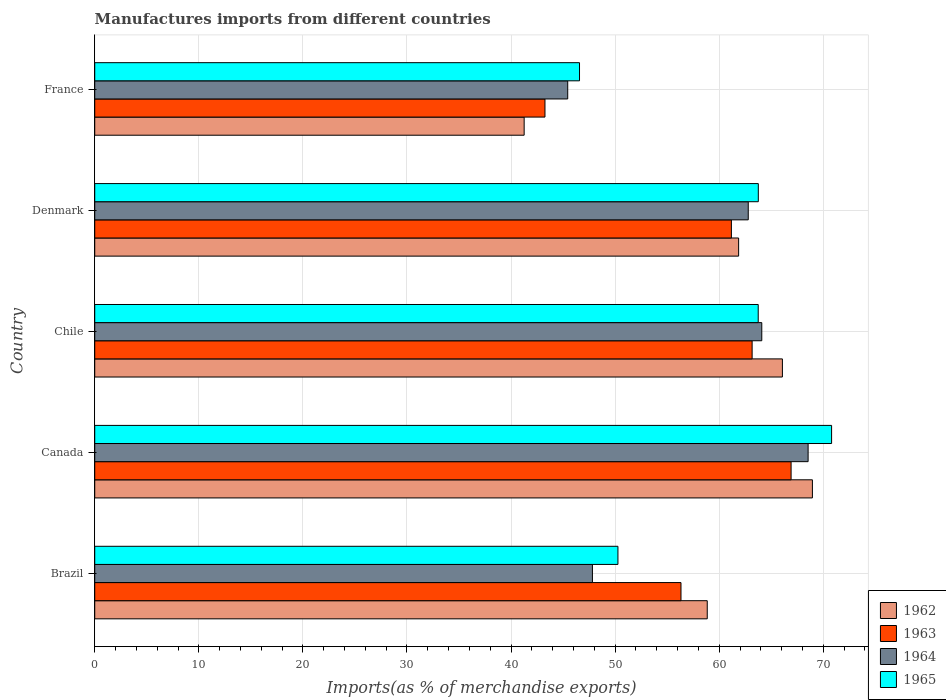How many different coloured bars are there?
Offer a very short reply. 4. How many groups of bars are there?
Your answer should be compact. 5. Are the number of bars per tick equal to the number of legend labels?
Provide a short and direct response. Yes. Are the number of bars on each tick of the Y-axis equal?
Your answer should be compact. Yes. How many bars are there on the 4th tick from the top?
Your answer should be compact. 4. What is the label of the 2nd group of bars from the top?
Offer a very short reply. Denmark. In how many cases, is the number of bars for a given country not equal to the number of legend labels?
Provide a short and direct response. 0. What is the percentage of imports to different countries in 1962 in Brazil?
Your answer should be very brief. 58.85. Across all countries, what is the maximum percentage of imports to different countries in 1965?
Give a very brief answer. 70.79. Across all countries, what is the minimum percentage of imports to different countries in 1962?
Offer a very short reply. 41.26. In which country was the percentage of imports to different countries in 1962 maximum?
Provide a succinct answer. Canada. What is the total percentage of imports to different countries in 1965 in the graph?
Your answer should be compact. 295.13. What is the difference between the percentage of imports to different countries in 1965 in Brazil and that in Chile?
Your response must be concise. -13.48. What is the difference between the percentage of imports to different countries in 1963 in France and the percentage of imports to different countries in 1962 in Canada?
Give a very brief answer. -25.69. What is the average percentage of imports to different countries in 1964 per country?
Make the answer very short. 57.73. What is the difference between the percentage of imports to different countries in 1962 and percentage of imports to different countries in 1963 in Canada?
Your response must be concise. 2.05. In how many countries, is the percentage of imports to different countries in 1964 greater than 14 %?
Your response must be concise. 5. What is the ratio of the percentage of imports to different countries in 1962 in Canada to that in France?
Ensure brevity in your answer.  1.67. Is the percentage of imports to different countries in 1964 in Chile less than that in Denmark?
Provide a short and direct response. No. Is the difference between the percentage of imports to different countries in 1962 in Chile and France greater than the difference between the percentage of imports to different countries in 1963 in Chile and France?
Make the answer very short. Yes. What is the difference between the highest and the second highest percentage of imports to different countries in 1964?
Provide a short and direct response. 4.45. What is the difference between the highest and the lowest percentage of imports to different countries in 1963?
Keep it short and to the point. 23.65. Is the sum of the percentage of imports to different countries in 1965 in Canada and Chile greater than the maximum percentage of imports to different countries in 1963 across all countries?
Offer a very short reply. Yes. Is it the case that in every country, the sum of the percentage of imports to different countries in 1965 and percentage of imports to different countries in 1963 is greater than the sum of percentage of imports to different countries in 1962 and percentage of imports to different countries in 1964?
Offer a very short reply. No. What does the 2nd bar from the top in Denmark represents?
Your answer should be very brief. 1964. What does the 4th bar from the bottom in Canada represents?
Your response must be concise. 1965. Is it the case that in every country, the sum of the percentage of imports to different countries in 1963 and percentage of imports to different countries in 1964 is greater than the percentage of imports to different countries in 1962?
Provide a succinct answer. Yes. Are all the bars in the graph horizontal?
Provide a short and direct response. Yes. How many countries are there in the graph?
Make the answer very short. 5. How many legend labels are there?
Your response must be concise. 4. What is the title of the graph?
Provide a succinct answer. Manufactures imports from different countries. What is the label or title of the X-axis?
Make the answer very short. Imports(as % of merchandise exports). What is the label or title of the Y-axis?
Provide a succinct answer. Country. What is the Imports(as % of merchandise exports) of 1962 in Brazil?
Offer a terse response. 58.85. What is the Imports(as % of merchandise exports) in 1963 in Brazil?
Give a very brief answer. 56.32. What is the Imports(as % of merchandise exports) of 1964 in Brazil?
Make the answer very short. 47.82. What is the Imports(as % of merchandise exports) of 1965 in Brazil?
Your answer should be very brief. 50.27. What is the Imports(as % of merchandise exports) in 1962 in Canada?
Offer a terse response. 68.95. What is the Imports(as % of merchandise exports) in 1963 in Canada?
Provide a short and direct response. 66.9. What is the Imports(as % of merchandise exports) of 1964 in Canada?
Your answer should be very brief. 68.54. What is the Imports(as % of merchandise exports) in 1965 in Canada?
Keep it short and to the point. 70.79. What is the Imports(as % of merchandise exports) of 1962 in Chile?
Offer a terse response. 66.07. What is the Imports(as % of merchandise exports) of 1963 in Chile?
Ensure brevity in your answer.  63.16. What is the Imports(as % of merchandise exports) of 1964 in Chile?
Your response must be concise. 64.09. What is the Imports(as % of merchandise exports) of 1965 in Chile?
Offer a very short reply. 63.74. What is the Imports(as % of merchandise exports) of 1962 in Denmark?
Your answer should be very brief. 61.86. What is the Imports(as % of merchandise exports) of 1963 in Denmark?
Provide a short and direct response. 61.17. What is the Imports(as % of merchandise exports) in 1964 in Denmark?
Make the answer very short. 62.79. What is the Imports(as % of merchandise exports) in 1965 in Denmark?
Make the answer very short. 63.75. What is the Imports(as % of merchandise exports) of 1962 in France?
Your response must be concise. 41.26. What is the Imports(as % of merchandise exports) of 1963 in France?
Offer a terse response. 43.26. What is the Imports(as % of merchandise exports) of 1964 in France?
Your response must be concise. 45.44. What is the Imports(as % of merchandise exports) in 1965 in France?
Offer a very short reply. 46.57. Across all countries, what is the maximum Imports(as % of merchandise exports) of 1962?
Your response must be concise. 68.95. Across all countries, what is the maximum Imports(as % of merchandise exports) of 1963?
Give a very brief answer. 66.9. Across all countries, what is the maximum Imports(as % of merchandise exports) of 1964?
Your answer should be very brief. 68.54. Across all countries, what is the maximum Imports(as % of merchandise exports) of 1965?
Make the answer very short. 70.79. Across all countries, what is the minimum Imports(as % of merchandise exports) in 1962?
Your response must be concise. 41.26. Across all countries, what is the minimum Imports(as % of merchandise exports) of 1963?
Offer a very short reply. 43.26. Across all countries, what is the minimum Imports(as % of merchandise exports) in 1964?
Give a very brief answer. 45.44. Across all countries, what is the minimum Imports(as % of merchandise exports) of 1965?
Offer a terse response. 46.57. What is the total Imports(as % of merchandise exports) of 1962 in the graph?
Make the answer very short. 296.98. What is the total Imports(as % of merchandise exports) of 1963 in the graph?
Provide a short and direct response. 290.81. What is the total Imports(as % of merchandise exports) in 1964 in the graph?
Your answer should be very brief. 288.67. What is the total Imports(as % of merchandise exports) in 1965 in the graph?
Make the answer very short. 295.13. What is the difference between the Imports(as % of merchandise exports) in 1962 in Brazil and that in Canada?
Your response must be concise. -10.1. What is the difference between the Imports(as % of merchandise exports) in 1963 in Brazil and that in Canada?
Offer a very short reply. -10.58. What is the difference between the Imports(as % of merchandise exports) of 1964 in Brazil and that in Canada?
Your answer should be compact. -20.72. What is the difference between the Imports(as % of merchandise exports) of 1965 in Brazil and that in Canada?
Offer a very short reply. -20.53. What is the difference between the Imports(as % of merchandise exports) of 1962 in Brazil and that in Chile?
Provide a short and direct response. -7.22. What is the difference between the Imports(as % of merchandise exports) in 1963 in Brazil and that in Chile?
Your answer should be very brief. -6.84. What is the difference between the Imports(as % of merchandise exports) of 1964 in Brazil and that in Chile?
Your answer should be compact. -16.27. What is the difference between the Imports(as % of merchandise exports) in 1965 in Brazil and that in Chile?
Your answer should be compact. -13.48. What is the difference between the Imports(as % of merchandise exports) of 1962 in Brazil and that in Denmark?
Make the answer very short. -3.01. What is the difference between the Imports(as % of merchandise exports) of 1963 in Brazil and that in Denmark?
Your response must be concise. -4.84. What is the difference between the Imports(as % of merchandise exports) of 1964 in Brazil and that in Denmark?
Make the answer very short. -14.97. What is the difference between the Imports(as % of merchandise exports) in 1965 in Brazil and that in Denmark?
Ensure brevity in your answer.  -13.49. What is the difference between the Imports(as % of merchandise exports) in 1962 in Brazil and that in France?
Offer a terse response. 17.59. What is the difference between the Imports(as % of merchandise exports) in 1963 in Brazil and that in France?
Offer a very short reply. 13.07. What is the difference between the Imports(as % of merchandise exports) in 1964 in Brazil and that in France?
Offer a very short reply. 2.37. What is the difference between the Imports(as % of merchandise exports) in 1965 in Brazil and that in France?
Provide a succinct answer. 3.69. What is the difference between the Imports(as % of merchandise exports) in 1962 in Canada and that in Chile?
Provide a short and direct response. 2.88. What is the difference between the Imports(as % of merchandise exports) in 1963 in Canada and that in Chile?
Keep it short and to the point. 3.74. What is the difference between the Imports(as % of merchandise exports) of 1964 in Canada and that in Chile?
Your response must be concise. 4.45. What is the difference between the Imports(as % of merchandise exports) of 1965 in Canada and that in Chile?
Your answer should be compact. 7.05. What is the difference between the Imports(as % of merchandise exports) in 1962 in Canada and that in Denmark?
Provide a short and direct response. 7.09. What is the difference between the Imports(as % of merchandise exports) of 1963 in Canada and that in Denmark?
Provide a short and direct response. 5.74. What is the difference between the Imports(as % of merchandise exports) in 1964 in Canada and that in Denmark?
Provide a succinct answer. 5.75. What is the difference between the Imports(as % of merchandise exports) of 1965 in Canada and that in Denmark?
Give a very brief answer. 7.04. What is the difference between the Imports(as % of merchandise exports) of 1962 in Canada and that in France?
Offer a terse response. 27.69. What is the difference between the Imports(as % of merchandise exports) in 1963 in Canada and that in France?
Your response must be concise. 23.65. What is the difference between the Imports(as % of merchandise exports) of 1964 in Canada and that in France?
Keep it short and to the point. 23.1. What is the difference between the Imports(as % of merchandise exports) in 1965 in Canada and that in France?
Give a very brief answer. 24.22. What is the difference between the Imports(as % of merchandise exports) of 1962 in Chile and that in Denmark?
Give a very brief answer. 4.21. What is the difference between the Imports(as % of merchandise exports) of 1963 in Chile and that in Denmark?
Your answer should be very brief. 1.99. What is the difference between the Imports(as % of merchandise exports) of 1964 in Chile and that in Denmark?
Your response must be concise. 1.3. What is the difference between the Imports(as % of merchandise exports) in 1965 in Chile and that in Denmark?
Keep it short and to the point. -0.01. What is the difference between the Imports(as % of merchandise exports) of 1962 in Chile and that in France?
Provide a succinct answer. 24.81. What is the difference between the Imports(as % of merchandise exports) of 1963 in Chile and that in France?
Your answer should be compact. 19.9. What is the difference between the Imports(as % of merchandise exports) of 1964 in Chile and that in France?
Keep it short and to the point. 18.64. What is the difference between the Imports(as % of merchandise exports) of 1965 in Chile and that in France?
Your answer should be very brief. 17.17. What is the difference between the Imports(as % of merchandise exports) of 1962 in Denmark and that in France?
Offer a very short reply. 20.61. What is the difference between the Imports(as % of merchandise exports) of 1963 in Denmark and that in France?
Your answer should be very brief. 17.91. What is the difference between the Imports(as % of merchandise exports) in 1964 in Denmark and that in France?
Keep it short and to the point. 17.34. What is the difference between the Imports(as % of merchandise exports) in 1965 in Denmark and that in France?
Make the answer very short. 17.18. What is the difference between the Imports(as % of merchandise exports) in 1962 in Brazil and the Imports(as % of merchandise exports) in 1963 in Canada?
Provide a succinct answer. -8.06. What is the difference between the Imports(as % of merchandise exports) of 1962 in Brazil and the Imports(as % of merchandise exports) of 1964 in Canada?
Your answer should be compact. -9.69. What is the difference between the Imports(as % of merchandise exports) in 1962 in Brazil and the Imports(as % of merchandise exports) in 1965 in Canada?
Provide a short and direct response. -11.95. What is the difference between the Imports(as % of merchandise exports) in 1963 in Brazil and the Imports(as % of merchandise exports) in 1964 in Canada?
Offer a very short reply. -12.21. What is the difference between the Imports(as % of merchandise exports) in 1963 in Brazil and the Imports(as % of merchandise exports) in 1965 in Canada?
Offer a terse response. -14.47. What is the difference between the Imports(as % of merchandise exports) of 1964 in Brazil and the Imports(as % of merchandise exports) of 1965 in Canada?
Your answer should be very brief. -22.98. What is the difference between the Imports(as % of merchandise exports) in 1962 in Brazil and the Imports(as % of merchandise exports) in 1963 in Chile?
Provide a short and direct response. -4.31. What is the difference between the Imports(as % of merchandise exports) in 1962 in Brazil and the Imports(as % of merchandise exports) in 1964 in Chile?
Your answer should be very brief. -5.24. What is the difference between the Imports(as % of merchandise exports) of 1962 in Brazil and the Imports(as % of merchandise exports) of 1965 in Chile?
Provide a succinct answer. -4.9. What is the difference between the Imports(as % of merchandise exports) of 1963 in Brazil and the Imports(as % of merchandise exports) of 1964 in Chile?
Your response must be concise. -7.76. What is the difference between the Imports(as % of merchandise exports) of 1963 in Brazil and the Imports(as % of merchandise exports) of 1965 in Chile?
Offer a terse response. -7.42. What is the difference between the Imports(as % of merchandise exports) in 1964 in Brazil and the Imports(as % of merchandise exports) in 1965 in Chile?
Keep it short and to the point. -15.93. What is the difference between the Imports(as % of merchandise exports) in 1962 in Brazil and the Imports(as % of merchandise exports) in 1963 in Denmark?
Your answer should be very brief. -2.32. What is the difference between the Imports(as % of merchandise exports) in 1962 in Brazil and the Imports(as % of merchandise exports) in 1964 in Denmark?
Provide a succinct answer. -3.94. What is the difference between the Imports(as % of merchandise exports) of 1962 in Brazil and the Imports(as % of merchandise exports) of 1965 in Denmark?
Provide a succinct answer. -4.91. What is the difference between the Imports(as % of merchandise exports) of 1963 in Brazil and the Imports(as % of merchandise exports) of 1964 in Denmark?
Make the answer very short. -6.46. What is the difference between the Imports(as % of merchandise exports) of 1963 in Brazil and the Imports(as % of merchandise exports) of 1965 in Denmark?
Your answer should be compact. -7.43. What is the difference between the Imports(as % of merchandise exports) of 1964 in Brazil and the Imports(as % of merchandise exports) of 1965 in Denmark?
Your answer should be compact. -15.94. What is the difference between the Imports(as % of merchandise exports) of 1962 in Brazil and the Imports(as % of merchandise exports) of 1963 in France?
Give a very brief answer. 15.59. What is the difference between the Imports(as % of merchandise exports) in 1962 in Brazil and the Imports(as % of merchandise exports) in 1964 in France?
Your response must be concise. 13.4. What is the difference between the Imports(as % of merchandise exports) in 1962 in Brazil and the Imports(as % of merchandise exports) in 1965 in France?
Your answer should be very brief. 12.27. What is the difference between the Imports(as % of merchandise exports) of 1963 in Brazil and the Imports(as % of merchandise exports) of 1964 in France?
Provide a short and direct response. 10.88. What is the difference between the Imports(as % of merchandise exports) of 1963 in Brazil and the Imports(as % of merchandise exports) of 1965 in France?
Your answer should be very brief. 9.75. What is the difference between the Imports(as % of merchandise exports) of 1964 in Brazil and the Imports(as % of merchandise exports) of 1965 in France?
Your answer should be compact. 1.24. What is the difference between the Imports(as % of merchandise exports) of 1962 in Canada and the Imports(as % of merchandise exports) of 1963 in Chile?
Ensure brevity in your answer.  5.79. What is the difference between the Imports(as % of merchandise exports) of 1962 in Canada and the Imports(as % of merchandise exports) of 1964 in Chile?
Ensure brevity in your answer.  4.86. What is the difference between the Imports(as % of merchandise exports) of 1962 in Canada and the Imports(as % of merchandise exports) of 1965 in Chile?
Keep it short and to the point. 5.21. What is the difference between the Imports(as % of merchandise exports) in 1963 in Canada and the Imports(as % of merchandise exports) in 1964 in Chile?
Ensure brevity in your answer.  2.82. What is the difference between the Imports(as % of merchandise exports) of 1963 in Canada and the Imports(as % of merchandise exports) of 1965 in Chile?
Your answer should be compact. 3.16. What is the difference between the Imports(as % of merchandise exports) of 1964 in Canada and the Imports(as % of merchandise exports) of 1965 in Chile?
Ensure brevity in your answer.  4.79. What is the difference between the Imports(as % of merchandise exports) of 1962 in Canada and the Imports(as % of merchandise exports) of 1963 in Denmark?
Ensure brevity in your answer.  7.78. What is the difference between the Imports(as % of merchandise exports) in 1962 in Canada and the Imports(as % of merchandise exports) in 1964 in Denmark?
Your response must be concise. 6.16. What is the difference between the Imports(as % of merchandise exports) in 1962 in Canada and the Imports(as % of merchandise exports) in 1965 in Denmark?
Provide a short and direct response. 5.2. What is the difference between the Imports(as % of merchandise exports) of 1963 in Canada and the Imports(as % of merchandise exports) of 1964 in Denmark?
Keep it short and to the point. 4.12. What is the difference between the Imports(as % of merchandise exports) of 1963 in Canada and the Imports(as % of merchandise exports) of 1965 in Denmark?
Make the answer very short. 3.15. What is the difference between the Imports(as % of merchandise exports) in 1964 in Canada and the Imports(as % of merchandise exports) in 1965 in Denmark?
Ensure brevity in your answer.  4.78. What is the difference between the Imports(as % of merchandise exports) in 1962 in Canada and the Imports(as % of merchandise exports) in 1963 in France?
Your response must be concise. 25.69. What is the difference between the Imports(as % of merchandise exports) of 1962 in Canada and the Imports(as % of merchandise exports) of 1964 in France?
Provide a succinct answer. 23.51. What is the difference between the Imports(as % of merchandise exports) in 1962 in Canada and the Imports(as % of merchandise exports) in 1965 in France?
Your response must be concise. 22.38. What is the difference between the Imports(as % of merchandise exports) of 1963 in Canada and the Imports(as % of merchandise exports) of 1964 in France?
Keep it short and to the point. 21.46. What is the difference between the Imports(as % of merchandise exports) in 1963 in Canada and the Imports(as % of merchandise exports) in 1965 in France?
Provide a succinct answer. 20.33. What is the difference between the Imports(as % of merchandise exports) in 1964 in Canada and the Imports(as % of merchandise exports) in 1965 in France?
Offer a very short reply. 21.96. What is the difference between the Imports(as % of merchandise exports) of 1962 in Chile and the Imports(as % of merchandise exports) of 1963 in Denmark?
Provide a short and direct response. 4.9. What is the difference between the Imports(as % of merchandise exports) in 1962 in Chile and the Imports(as % of merchandise exports) in 1964 in Denmark?
Give a very brief answer. 3.28. What is the difference between the Imports(as % of merchandise exports) in 1962 in Chile and the Imports(as % of merchandise exports) in 1965 in Denmark?
Your answer should be very brief. 2.31. What is the difference between the Imports(as % of merchandise exports) in 1963 in Chile and the Imports(as % of merchandise exports) in 1964 in Denmark?
Keep it short and to the point. 0.37. What is the difference between the Imports(as % of merchandise exports) in 1963 in Chile and the Imports(as % of merchandise exports) in 1965 in Denmark?
Offer a terse response. -0.59. What is the difference between the Imports(as % of merchandise exports) in 1962 in Chile and the Imports(as % of merchandise exports) in 1963 in France?
Keep it short and to the point. 22.81. What is the difference between the Imports(as % of merchandise exports) of 1962 in Chile and the Imports(as % of merchandise exports) of 1964 in France?
Your answer should be very brief. 20.63. What is the difference between the Imports(as % of merchandise exports) of 1962 in Chile and the Imports(as % of merchandise exports) of 1965 in France?
Provide a short and direct response. 19.49. What is the difference between the Imports(as % of merchandise exports) of 1963 in Chile and the Imports(as % of merchandise exports) of 1964 in France?
Offer a very short reply. 17.72. What is the difference between the Imports(as % of merchandise exports) of 1963 in Chile and the Imports(as % of merchandise exports) of 1965 in France?
Give a very brief answer. 16.58. What is the difference between the Imports(as % of merchandise exports) of 1964 in Chile and the Imports(as % of merchandise exports) of 1965 in France?
Provide a short and direct response. 17.51. What is the difference between the Imports(as % of merchandise exports) of 1962 in Denmark and the Imports(as % of merchandise exports) of 1963 in France?
Offer a very short reply. 18.61. What is the difference between the Imports(as % of merchandise exports) in 1962 in Denmark and the Imports(as % of merchandise exports) in 1964 in France?
Your answer should be compact. 16.42. What is the difference between the Imports(as % of merchandise exports) in 1962 in Denmark and the Imports(as % of merchandise exports) in 1965 in France?
Ensure brevity in your answer.  15.29. What is the difference between the Imports(as % of merchandise exports) of 1963 in Denmark and the Imports(as % of merchandise exports) of 1964 in France?
Your answer should be very brief. 15.72. What is the difference between the Imports(as % of merchandise exports) in 1963 in Denmark and the Imports(as % of merchandise exports) in 1965 in France?
Provide a short and direct response. 14.59. What is the difference between the Imports(as % of merchandise exports) in 1964 in Denmark and the Imports(as % of merchandise exports) in 1965 in France?
Your answer should be compact. 16.21. What is the average Imports(as % of merchandise exports) in 1962 per country?
Offer a terse response. 59.4. What is the average Imports(as % of merchandise exports) in 1963 per country?
Your answer should be compact. 58.16. What is the average Imports(as % of merchandise exports) in 1964 per country?
Offer a very short reply. 57.73. What is the average Imports(as % of merchandise exports) of 1965 per country?
Your response must be concise. 59.03. What is the difference between the Imports(as % of merchandise exports) of 1962 and Imports(as % of merchandise exports) of 1963 in Brazil?
Make the answer very short. 2.52. What is the difference between the Imports(as % of merchandise exports) in 1962 and Imports(as % of merchandise exports) in 1964 in Brazil?
Ensure brevity in your answer.  11.03. What is the difference between the Imports(as % of merchandise exports) of 1962 and Imports(as % of merchandise exports) of 1965 in Brazil?
Keep it short and to the point. 8.58. What is the difference between the Imports(as % of merchandise exports) in 1963 and Imports(as % of merchandise exports) in 1964 in Brazil?
Ensure brevity in your answer.  8.51. What is the difference between the Imports(as % of merchandise exports) in 1963 and Imports(as % of merchandise exports) in 1965 in Brazil?
Provide a succinct answer. 6.06. What is the difference between the Imports(as % of merchandise exports) in 1964 and Imports(as % of merchandise exports) in 1965 in Brazil?
Your response must be concise. -2.45. What is the difference between the Imports(as % of merchandise exports) of 1962 and Imports(as % of merchandise exports) of 1963 in Canada?
Offer a terse response. 2.05. What is the difference between the Imports(as % of merchandise exports) in 1962 and Imports(as % of merchandise exports) in 1964 in Canada?
Provide a succinct answer. 0.41. What is the difference between the Imports(as % of merchandise exports) in 1962 and Imports(as % of merchandise exports) in 1965 in Canada?
Your response must be concise. -1.84. What is the difference between the Imports(as % of merchandise exports) in 1963 and Imports(as % of merchandise exports) in 1964 in Canada?
Give a very brief answer. -1.64. What is the difference between the Imports(as % of merchandise exports) in 1963 and Imports(as % of merchandise exports) in 1965 in Canada?
Offer a very short reply. -3.89. What is the difference between the Imports(as % of merchandise exports) of 1964 and Imports(as % of merchandise exports) of 1965 in Canada?
Offer a very short reply. -2.26. What is the difference between the Imports(as % of merchandise exports) in 1962 and Imports(as % of merchandise exports) in 1963 in Chile?
Your answer should be compact. 2.91. What is the difference between the Imports(as % of merchandise exports) of 1962 and Imports(as % of merchandise exports) of 1964 in Chile?
Provide a succinct answer. 1.98. What is the difference between the Imports(as % of merchandise exports) of 1962 and Imports(as % of merchandise exports) of 1965 in Chile?
Keep it short and to the point. 2.32. What is the difference between the Imports(as % of merchandise exports) in 1963 and Imports(as % of merchandise exports) in 1964 in Chile?
Offer a terse response. -0.93. What is the difference between the Imports(as % of merchandise exports) in 1963 and Imports(as % of merchandise exports) in 1965 in Chile?
Provide a succinct answer. -0.59. What is the difference between the Imports(as % of merchandise exports) in 1964 and Imports(as % of merchandise exports) in 1965 in Chile?
Provide a succinct answer. 0.34. What is the difference between the Imports(as % of merchandise exports) in 1962 and Imports(as % of merchandise exports) in 1963 in Denmark?
Provide a short and direct response. 0.69. What is the difference between the Imports(as % of merchandise exports) of 1962 and Imports(as % of merchandise exports) of 1964 in Denmark?
Keep it short and to the point. -0.92. What is the difference between the Imports(as % of merchandise exports) in 1962 and Imports(as % of merchandise exports) in 1965 in Denmark?
Provide a succinct answer. -1.89. What is the difference between the Imports(as % of merchandise exports) in 1963 and Imports(as % of merchandise exports) in 1964 in Denmark?
Give a very brief answer. -1.62. What is the difference between the Imports(as % of merchandise exports) of 1963 and Imports(as % of merchandise exports) of 1965 in Denmark?
Provide a succinct answer. -2.59. What is the difference between the Imports(as % of merchandise exports) in 1964 and Imports(as % of merchandise exports) in 1965 in Denmark?
Provide a succinct answer. -0.97. What is the difference between the Imports(as % of merchandise exports) in 1962 and Imports(as % of merchandise exports) in 1963 in France?
Offer a very short reply. -2. What is the difference between the Imports(as % of merchandise exports) of 1962 and Imports(as % of merchandise exports) of 1964 in France?
Your response must be concise. -4.19. What is the difference between the Imports(as % of merchandise exports) of 1962 and Imports(as % of merchandise exports) of 1965 in France?
Your answer should be compact. -5.32. What is the difference between the Imports(as % of merchandise exports) in 1963 and Imports(as % of merchandise exports) in 1964 in France?
Provide a short and direct response. -2.19. What is the difference between the Imports(as % of merchandise exports) of 1963 and Imports(as % of merchandise exports) of 1965 in France?
Your answer should be compact. -3.32. What is the difference between the Imports(as % of merchandise exports) in 1964 and Imports(as % of merchandise exports) in 1965 in France?
Give a very brief answer. -1.13. What is the ratio of the Imports(as % of merchandise exports) of 1962 in Brazil to that in Canada?
Provide a succinct answer. 0.85. What is the ratio of the Imports(as % of merchandise exports) of 1963 in Brazil to that in Canada?
Your answer should be very brief. 0.84. What is the ratio of the Imports(as % of merchandise exports) in 1964 in Brazil to that in Canada?
Give a very brief answer. 0.7. What is the ratio of the Imports(as % of merchandise exports) of 1965 in Brazil to that in Canada?
Offer a very short reply. 0.71. What is the ratio of the Imports(as % of merchandise exports) of 1962 in Brazil to that in Chile?
Provide a succinct answer. 0.89. What is the ratio of the Imports(as % of merchandise exports) of 1963 in Brazil to that in Chile?
Provide a short and direct response. 0.89. What is the ratio of the Imports(as % of merchandise exports) in 1964 in Brazil to that in Chile?
Provide a succinct answer. 0.75. What is the ratio of the Imports(as % of merchandise exports) of 1965 in Brazil to that in Chile?
Provide a succinct answer. 0.79. What is the ratio of the Imports(as % of merchandise exports) in 1962 in Brazil to that in Denmark?
Make the answer very short. 0.95. What is the ratio of the Imports(as % of merchandise exports) in 1963 in Brazil to that in Denmark?
Your answer should be compact. 0.92. What is the ratio of the Imports(as % of merchandise exports) of 1964 in Brazil to that in Denmark?
Your answer should be very brief. 0.76. What is the ratio of the Imports(as % of merchandise exports) of 1965 in Brazil to that in Denmark?
Your answer should be compact. 0.79. What is the ratio of the Imports(as % of merchandise exports) of 1962 in Brazil to that in France?
Provide a short and direct response. 1.43. What is the ratio of the Imports(as % of merchandise exports) of 1963 in Brazil to that in France?
Give a very brief answer. 1.3. What is the ratio of the Imports(as % of merchandise exports) of 1964 in Brazil to that in France?
Offer a terse response. 1.05. What is the ratio of the Imports(as % of merchandise exports) in 1965 in Brazil to that in France?
Your answer should be very brief. 1.08. What is the ratio of the Imports(as % of merchandise exports) of 1962 in Canada to that in Chile?
Your answer should be very brief. 1.04. What is the ratio of the Imports(as % of merchandise exports) of 1963 in Canada to that in Chile?
Make the answer very short. 1.06. What is the ratio of the Imports(as % of merchandise exports) in 1964 in Canada to that in Chile?
Your response must be concise. 1.07. What is the ratio of the Imports(as % of merchandise exports) of 1965 in Canada to that in Chile?
Keep it short and to the point. 1.11. What is the ratio of the Imports(as % of merchandise exports) in 1962 in Canada to that in Denmark?
Give a very brief answer. 1.11. What is the ratio of the Imports(as % of merchandise exports) in 1963 in Canada to that in Denmark?
Offer a terse response. 1.09. What is the ratio of the Imports(as % of merchandise exports) in 1964 in Canada to that in Denmark?
Your answer should be very brief. 1.09. What is the ratio of the Imports(as % of merchandise exports) in 1965 in Canada to that in Denmark?
Offer a very short reply. 1.11. What is the ratio of the Imports(as % of merchandise exports) of 1962 in Canada to that in France?
Offer a very short reply. 1.67. What is the ratio of the Imports(as % of merchandise exports) of 1963 in Canada to that in France?
Keep it short and to the point. 1.55. What is the ratio of the Imports(as % of merchandise exports) of 1964 in Canada to that in France?
Offer a terse response. 1.51. What is the ratio of the Imports(as % of merchandise exports) of 1965 in Canada to that in France?
Your answer should be very brief. 1.52. What is the ratio of the Imports(as % of merchandise exports) of 1962 in Chile to that in Denmark?
Offer a very short reply. 1.07. What is the ratio of the Imports(as % of merchandise exports) in 1963 in Chile to that in Denmark?
Your answer should be very brief. 1.03. What is the ratio of the Imports(as % of merchandise exports) of 1964 in Chile to that in Denmark?
Provide a succinct answer. 1.02. What is the ratio of the Imports(as % of merchandise exports) in 1965 in Chile to that in Denmark?
Provide a succinct answer. 1. What is the ratio of the Imports(as % of merchandise exports) of 1962 in Chile to that in France?
Your response must be concise. 1.6. What is the ratio of the Imports(as % of merchandise exports) of 1963 in Chile to that in France?
Your answer should be very brief. 1.46. What is the ratio of the Imports(as % of merchandise exports) of 1964 in Chile to that in France?
Provide a succinct answer. 1.41. What is the ratio of the Imports(as % of merchandise exports) in 1965 in Chile to that in France?
Provide a succinct answer. 1.37. What is the ratio of the Imports(as % of merchandise exports) in 1962 in Denmark to that in France?
Make the answer very short. 1.5. What is the ratio of the Imports(as % of merchandise exports) in 1963 in Denmark to that in France?
Offer a very short reply. 1.41. What is the ratio of the Imports(as % of merchandise exports) of 1964 in Denmark to that in France?
Your answer should be very brief. 1.38. What is the ratio of the Imports(as % of merchandise exports) of 1965 in Denmark to that in France?
Provide a succinct answer. 1.37. What is the difference between the highest and the second highest Imports(as % of merchandise exports) in 1962?
Make the answer very short. 2.88. What is the difference between the highest and the second highest Imports(as % of merchandise exports) of 1963?
Ensure brevity in your answer.  3.74. What is the difference between the highest and the second highest Imports(as % of merchandise exports) of 1964?
Offer a terse response. 4.45. What is the difference between the highest and the second highest Imports(as % of merchandise exports) of 1965?
Your answer should be compact. 7.04. What is the difference between the highest and the lowest Imports(as % of merchandise exports) of 1962?
Give a very brief answer. 27.69. What is the difference between the highest and the lowest Imports(as % of merchandise exports) of 1963?
Give a very brief answer. 23.65. What is the difference between the highest and the lowest Imports(as % of merchandise exports) of 1964?
Offer a terse response. 23.1. What is the difference between the highest and the lowest Imports(as % of merchandise exports) in 1965?
Your response must be concise. 24.22. 